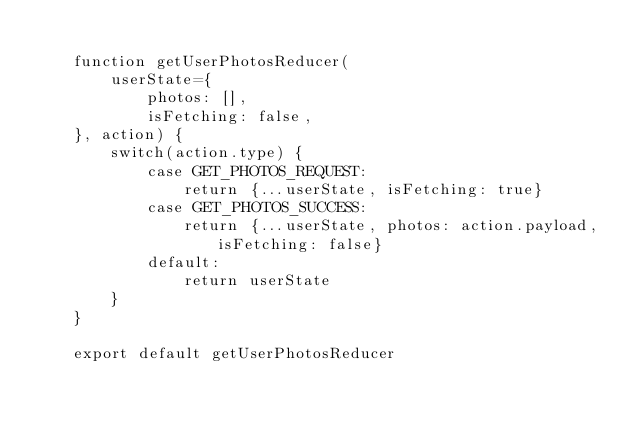<code> <loc_0><loc_0><loc_500><loc_500><_JavaScript_>
	function getUserPhotosReducer(
		userState={
			photos: [],
			isFetching: false,
	}, action) {
		switch(action.type) {
			case GET_PHOTOS_REQUEST:
				return {...userState, isFetching: true}
			case GET_PHOTOS_SUCCESS:
				return {...userState, photos: action.payload, isFetching: false}
			default:
				return userState
		}
	}

	export default getUserPhotosReducer
</code> 